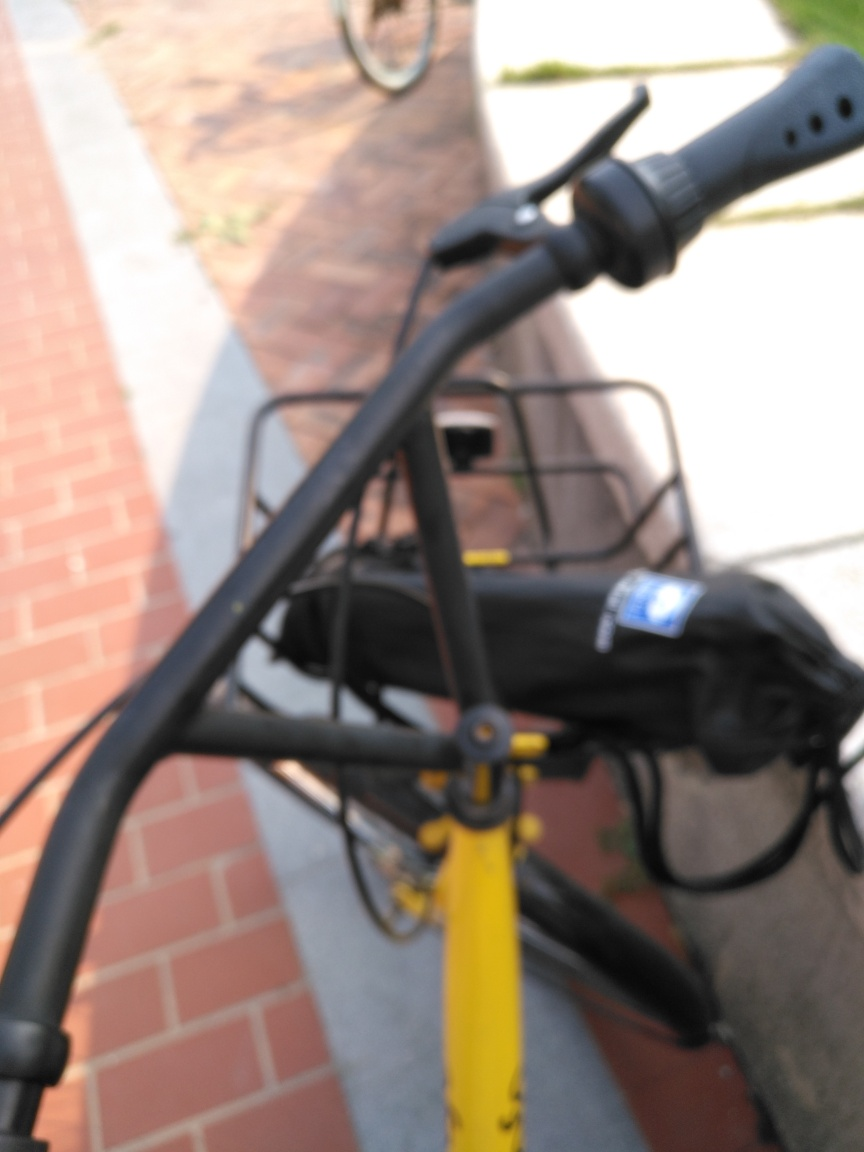Is the main subject clear and detailed in the image? The main subject appears to be a bicycle; however, the image is out of focus, which hinders clarity and detail. The intent seems to capture the essence of a bicycle in motion or to emphasize the hurried pace of life, but the details of the bike are not visible due to the lack of focus. 